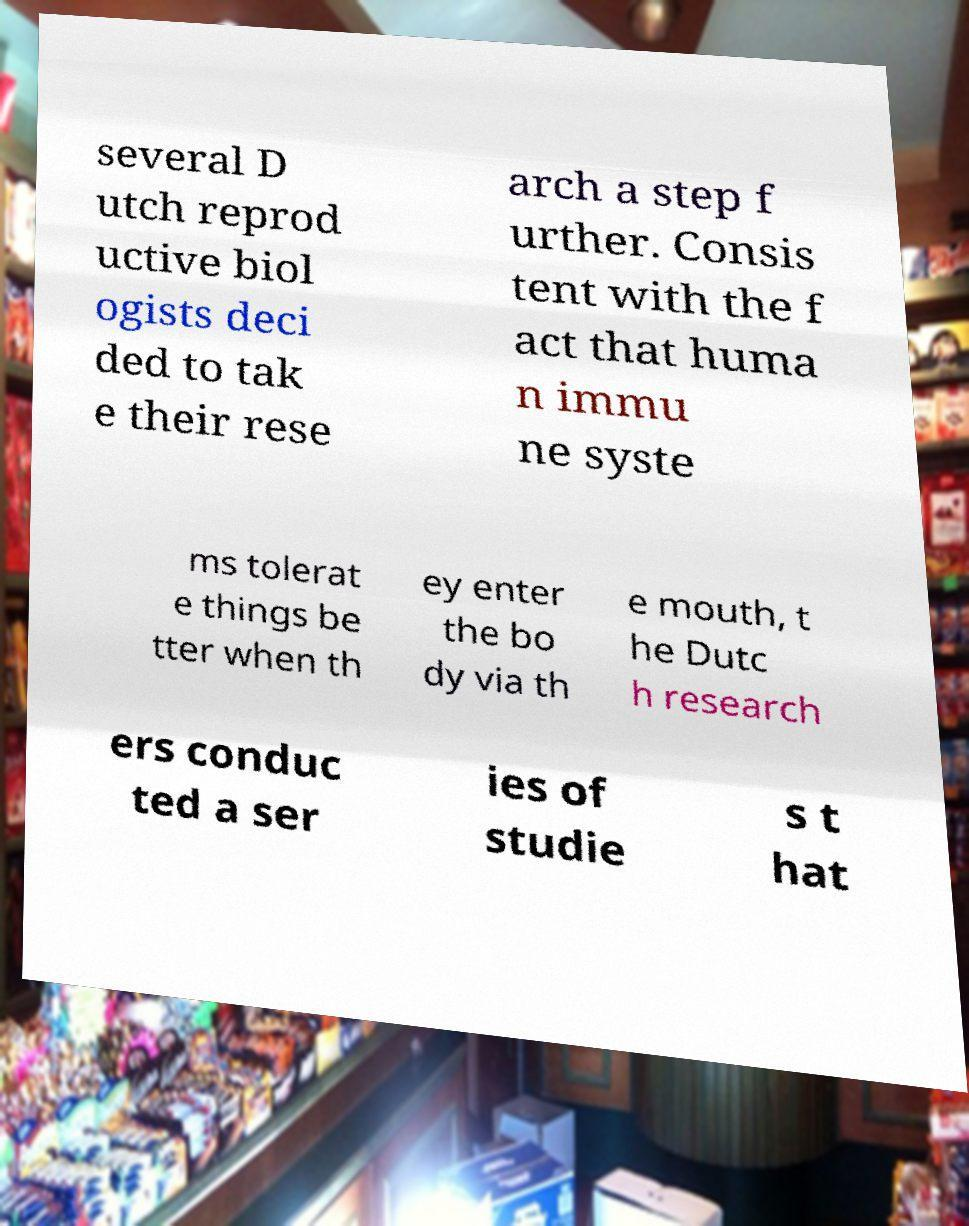Can you accurately transcribe the text from the provided image for me? several D utch reprod uctive biol ogists deci ded to tak e their rese arch a step f urther. Consis tent with the f act that huma n immu ne syste ms tolerat e things be tter when th ey enter the bo dy via th e mouth, t he Dutc h research ers conduc ted a ser ies of studie s t hat 